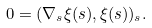<formula> <loc_0><loc_0><loc_500><loc_500>0 = ( \nabla _ { s } \xi ( s ) , \xi ( s ) ) _ { s } .</formula> 